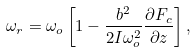<formula> <loc_0><loc_0><loc_500><loc_500>\omega _ { r } = \omega _ { o } \left [ 1 - \frac { b ^ { 2 } } { 2 I \omega _ { o } ^ { 2 } } \frac { \partial F _ { c } } { \partial z } \right ] ,</formula> 